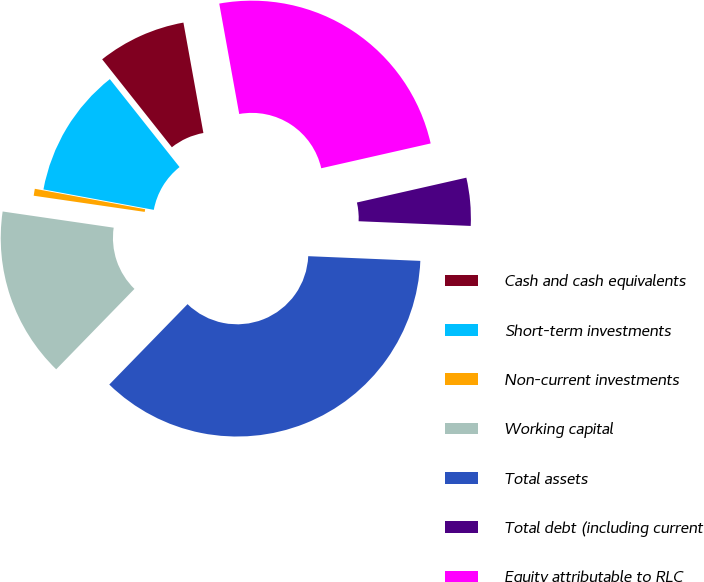Convert chart. <chart><loc_0><loc_0><loc_500><loc_500><pie_chart><fcel>Cash and cash equivalents<fcel>Short-term investments<fcel>Non-current investments<fcel>Working capital<fcel>Total assets<fcel>Total debt (including current<fcel>Equity attributable to RLC<nl><fcel>7.82%<fcel>11.42%<fcel>0.61%<fcel>15.02%<fcel>36.62%<fcel>4.22%<fcel>24.3%<nl></chart> 